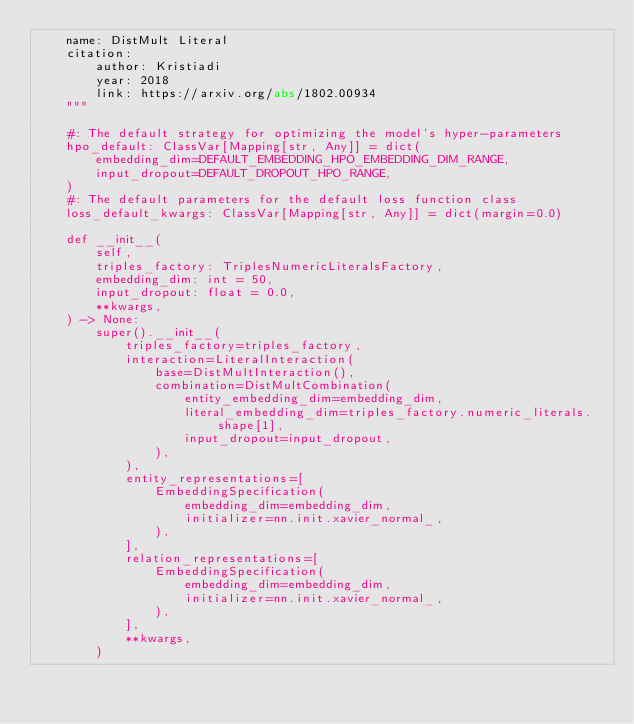<code> <loc_0><loc_0><loc_500><loc_500><_Python_>    name: DistMult Literal
    citation:
        author: Kristiadi
        year: 2018
        link: https://arxiv.org/abs/1802.00934
    """

    #: The default strategy for optimizing the model's hyper-parameters
    hpo_default: ClassVar[Mapping[str, Any]] = dict(
        embedding_dim=DEFAULT_EMBEDDING_HPO_EMBEDDING_DIM_RANGE,
        input_dropout=DEFAULT_DROPOUT_HPO_RANGE,
    )
    #: The default parameters for the default loss function class
    loss_default_kwargs: ClassVar[Mapping[str, Any]] = dict(margin=0.0)

    def __init__(
        self,
        triples_factory: TriplesNumericLiteralsFactory,
        embedding_dim: int = 50,
        input_dropout: float = 0.0,
        **kwargs,
    ) -> None:
        super().__init__(
            triples_factory=triples_factory,
            interaction=LiteralInteraction(
                base=DistMultInteraction(),
                combination=DistMultCombination(
                    entity_embedding_dim=embedding_dim,
                    literal_embedding_dim=triples_factory.numeric_literals.shape[1],
                    input_dropout=input_dropout,
                ),
            ),
            entity_representations=[
                EmbeddingSpecification(
                    embedding_dim=embedding_dim,
                    initializer=nn.init.xavier_normal_,
                ),
            ],
            relation_representations=[
                EmbeddingSpecification(
                    embedding_dim=embedding_dim,
                    initializer=nn.init.xavier_normal_,
                ),
            ],
            **kwargs,
        )
</code> 